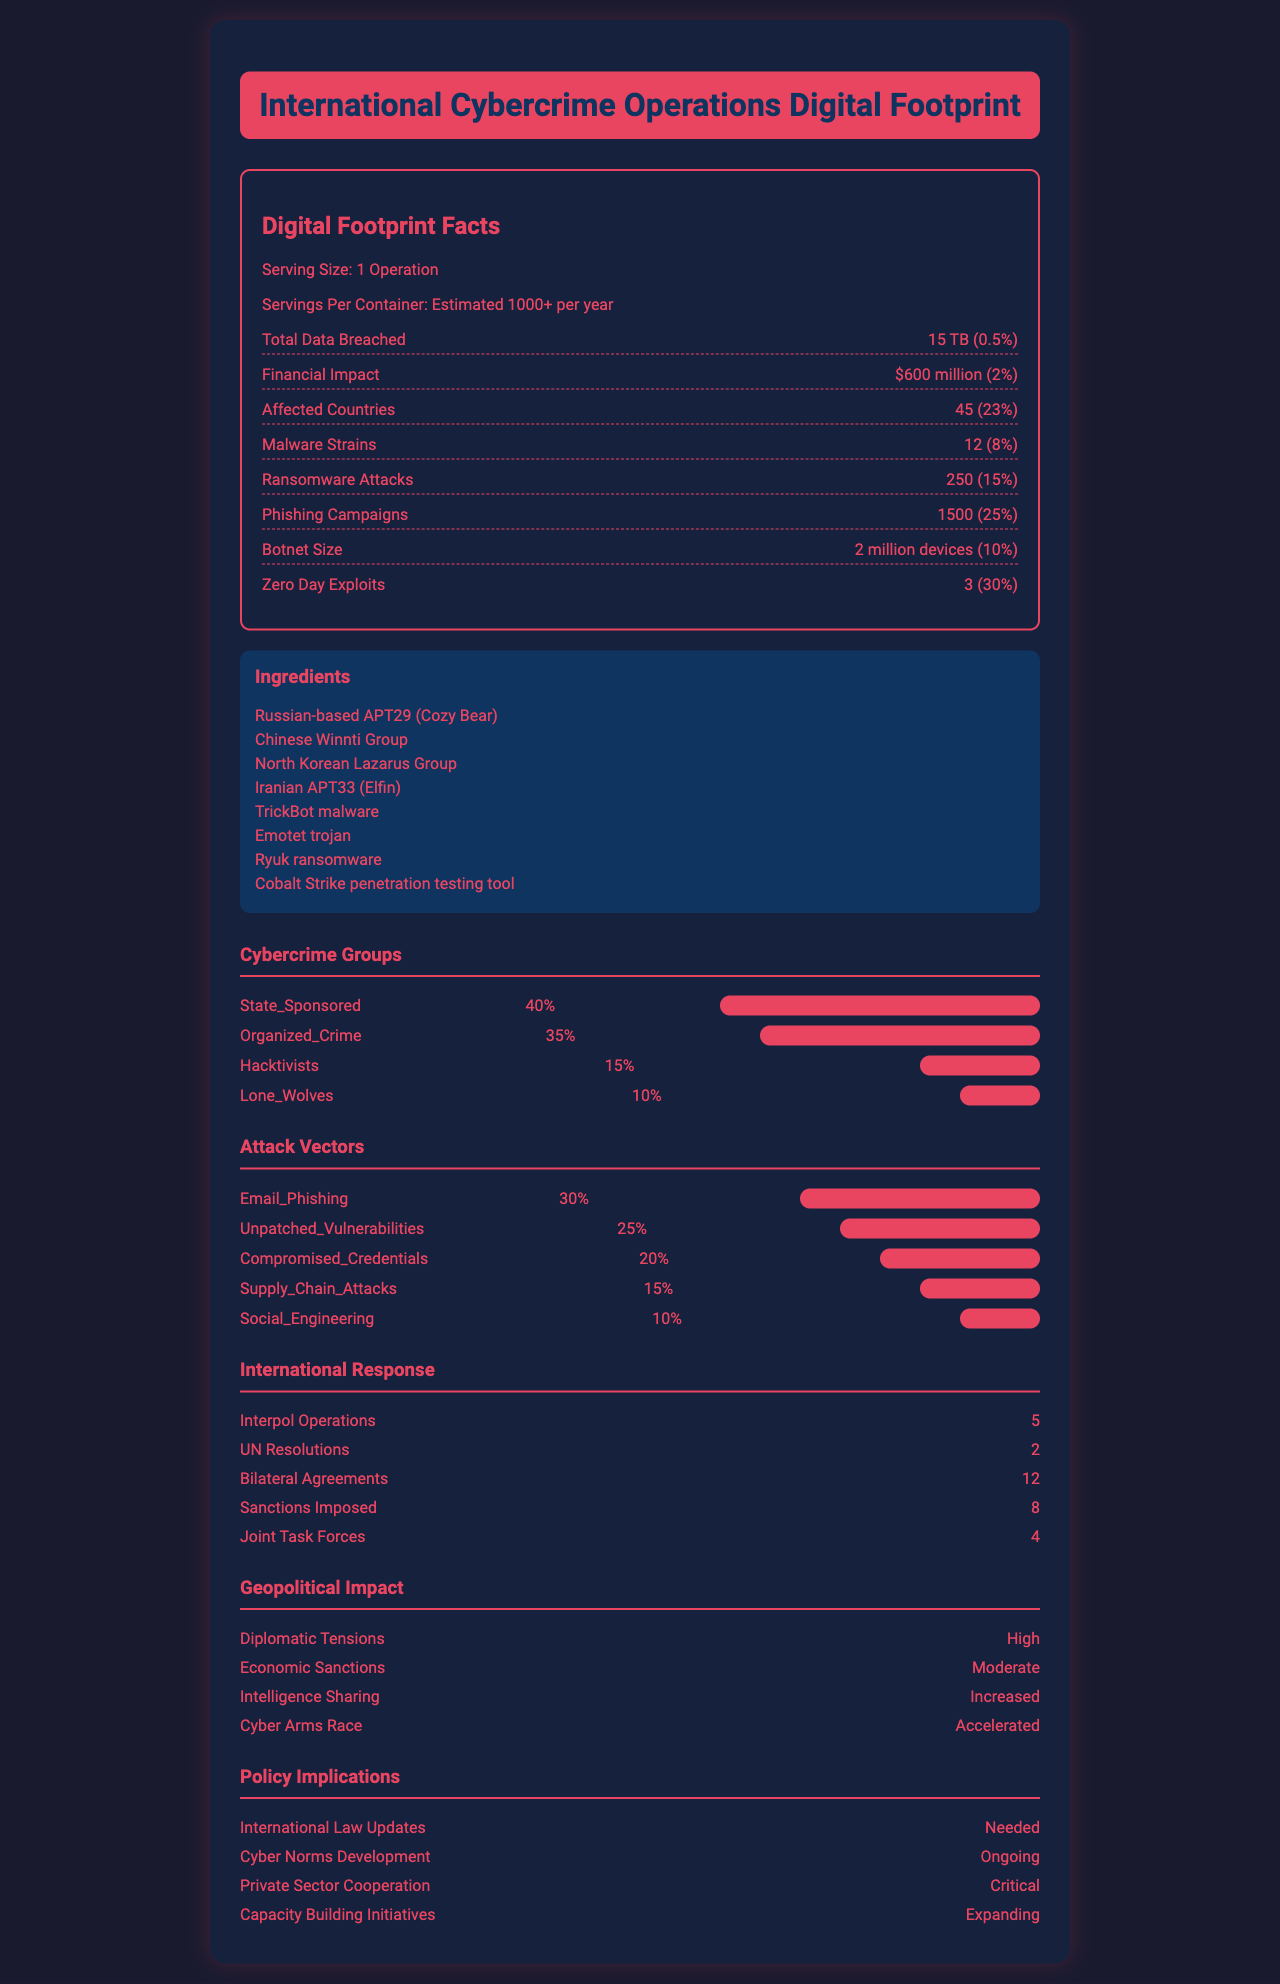what is the serving size for the International Cybercrime Operations Digital Footprint? The document states that the serving size is "1 Operation".
Answer: 1 Operation how many ransomware attacks are included in a single operation? The nutritional facts indicate that there are 250 ransomware attacks in one operation.
Answer: 250 which cybercrime group contributes 40% to the digital footprint? The chart under Cybercrime Groups shows that State-Sponsored groups contribute 40%.
Answer: State-Sponsored how many affected countries does an average operation impact? The document mentions that there are 45 affected countries in one operation.
Answer: 45 name two ingredients that are part of the digital footprint of an operation The ingredient list includes Russian-based APT29 (Cozy Bear) and the Chinese Winnti Group, among others.
Answer: Russian-based APT29 (Cozy Bear), Chinese Winnti Group how many devices are in the botnet associated with an operation? The nutritional facts list the botnet size as 2 million devices.
Answer: 2 million devices which of the following groups has the smallest contribution to cybercrime operations? A. State-Sponsored B. Organized Crime C. Hacktivists D. Lone Wolves Lone Wolves have a 10% contribution, the smallest compared to other groups.
Answer: D what percentage of attack vectors are attributed to email phishing? A. 10% B. 25% C. 30% D. 35% The attack vectors chart indicates that email phishing accounts for 30%.
Answer: C is there an aspect of the document detailing social engineering attacks? The document includes Social Engineering as an attack vector with 10%.
Answer: Yes summarize the main idea of the document The summary explanation encompasses all aspects detailed within the document, including statistical data, types of attacks, involved entities, and the responses by international bodies, highlighting the comprehensive scale and varied impact of cybercrime operations.
Answer: The document provides a detailed breakdown of the digital footprint of International Cybercrime Operations, including the scope, impact, types of attacks, involved cybercrime groups, and the international response. It highlights data breached, financial impact, and affected regions, along with policy implications and geopolitical impacts. how often are Interpol operations conducted in response to cybercrime? The international response section mentions that there are 5 Interpol operations.
Answer: 5 which group is not listed in the ingredients? The ingredients list several groups and tools involved in cybercrime operations, but the question requires comparing to another source that is not provided within this document.
Answer: Not enough information 